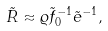<formula> <loc_0><loc_0><loc_500><loc_500>\tilde { R } \approx \varrho \tilde { f } _ { 0 } ^ { - 1 } \tilde { e } ^ { - 1 } ,</formula> 